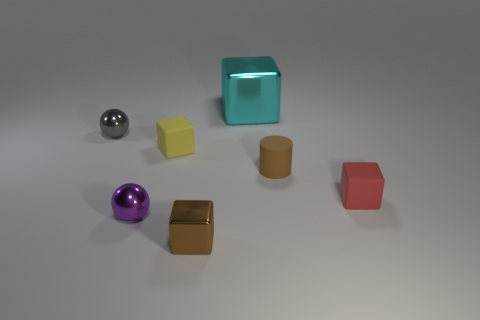If the objects were used in a physics demonstration, what properties could they illustrate? These objects could serve to demonstrate a variety of physical properties. For instance, the spheres could illustrate concepts of rolling friction and spherical symmetry in motion. The translucent cube could be used to show light refraction and the principles of transparency, while the matte cubes might be useful to discuss the reflection and absorption of light. The brown cylindrical object could demonstrate stability and center of gravity. The differences in reflectivity and color could also be utilized to discuss properties of materials and how they interact with light. 